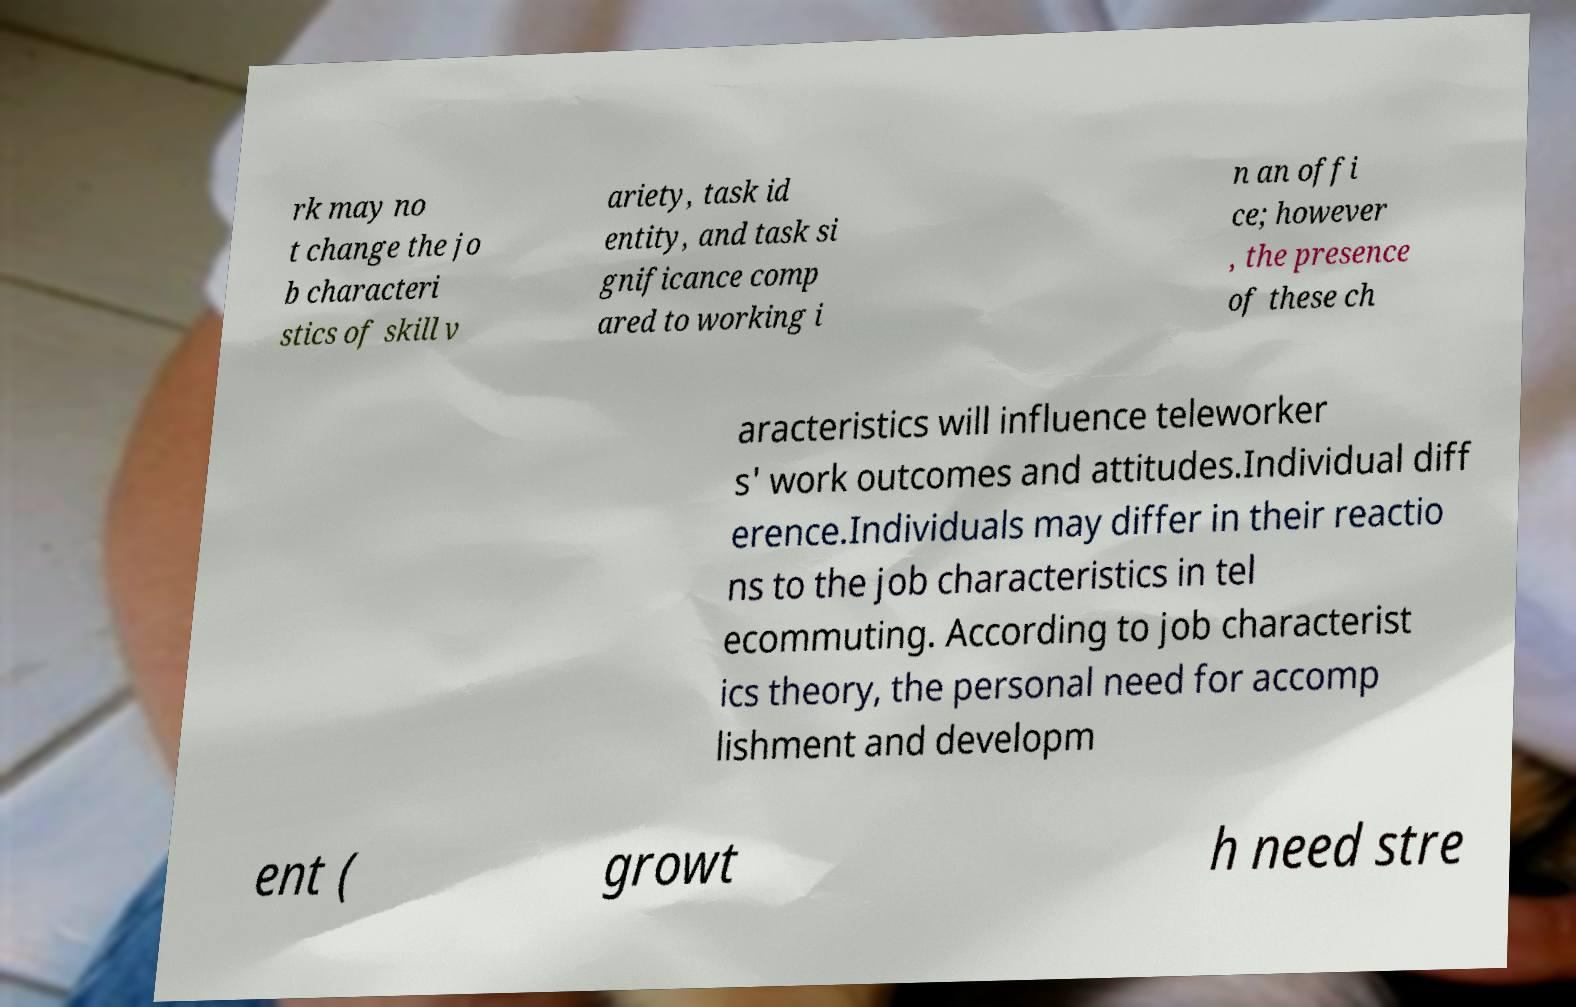I need the written content from this picture converted into text. Can you do that? rk may no t change the jo b characteri stics of skill v ariety, task id entity, and task si gnificance comp ared to working i n an offi ce; however , the presence of these ch aracteristics will influence teleworker s' work outcomes and attitudes.Individual diff erence.Individuals may differ in their reactio ns to the job characteristics in tel ecommuting. According to job characterist ics theory, the personal need for accomp lishment and developm ent ( growt h need stre 